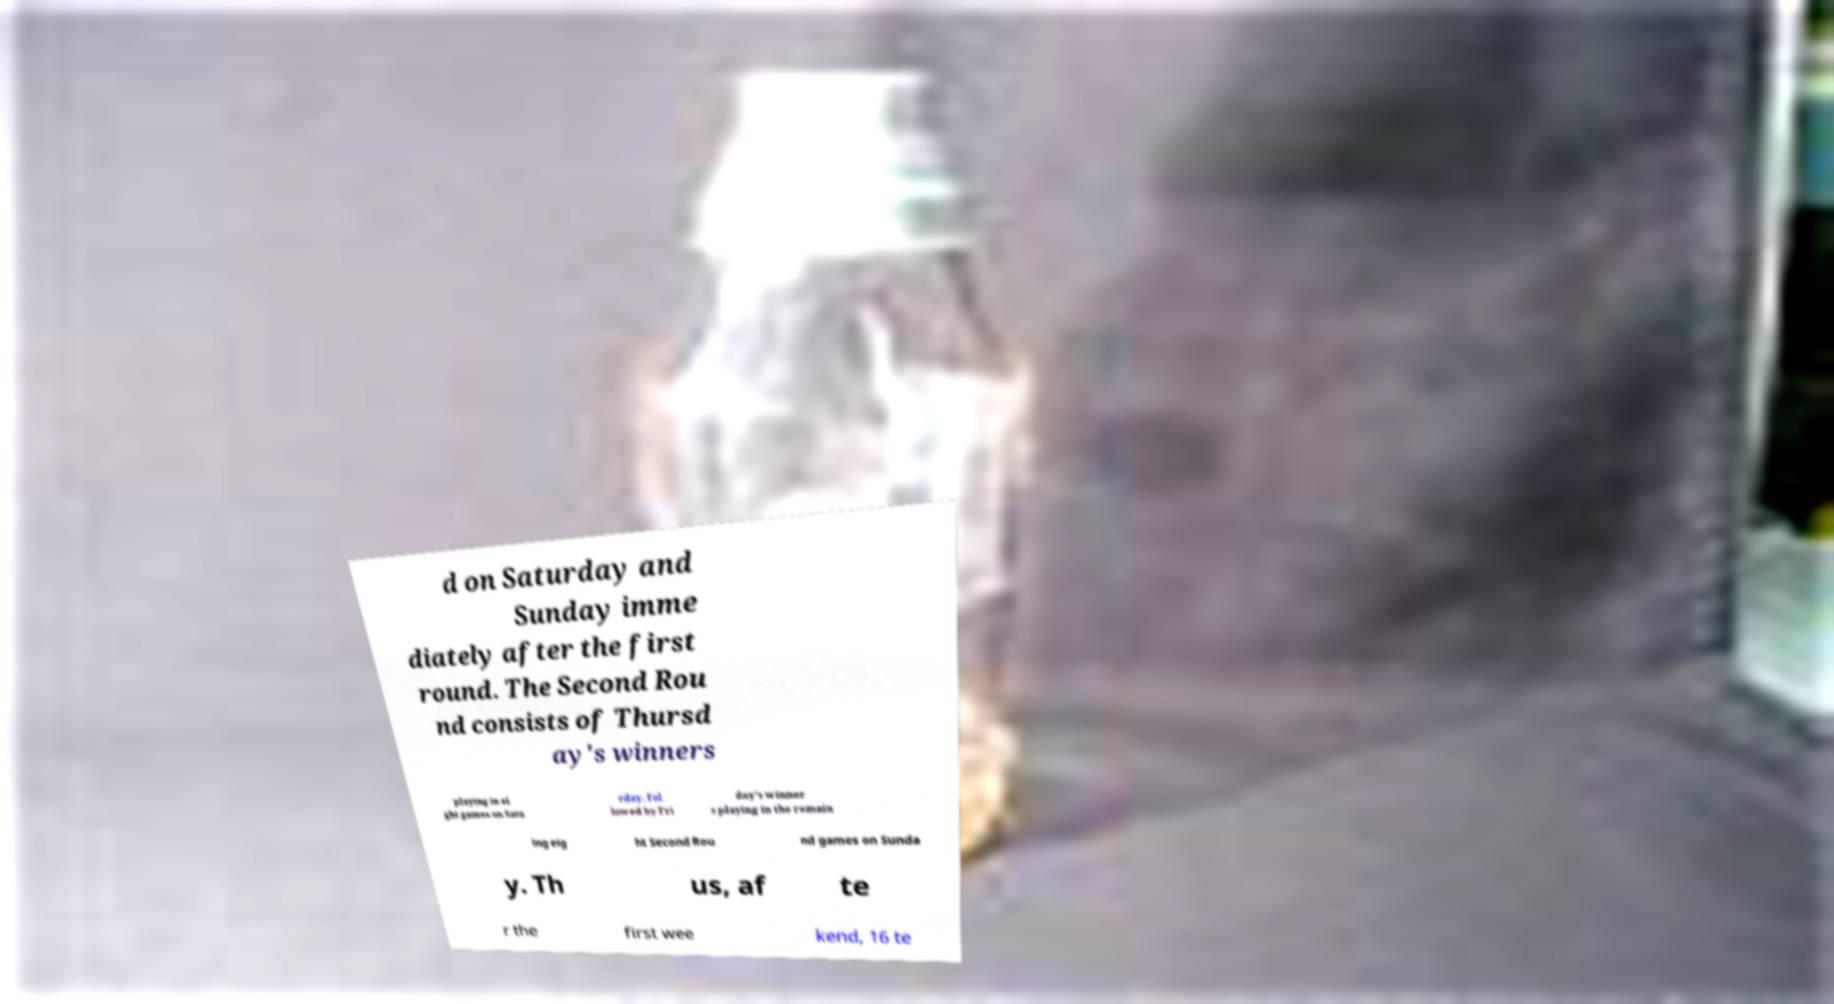There's text embedded in this image that I need extracted. Can you transcribe it verbatim? d on Saturday and Sunday imme diately after the first round. The Second Rou nd consists of Thursd ay's winners playing in ei ght games on Satu rday, fol lowed by Fri day's winner s playing in the remain ing eig ht Second Rou nd games on Sunda y. Th us, af te r the first wee kend, 16 te 